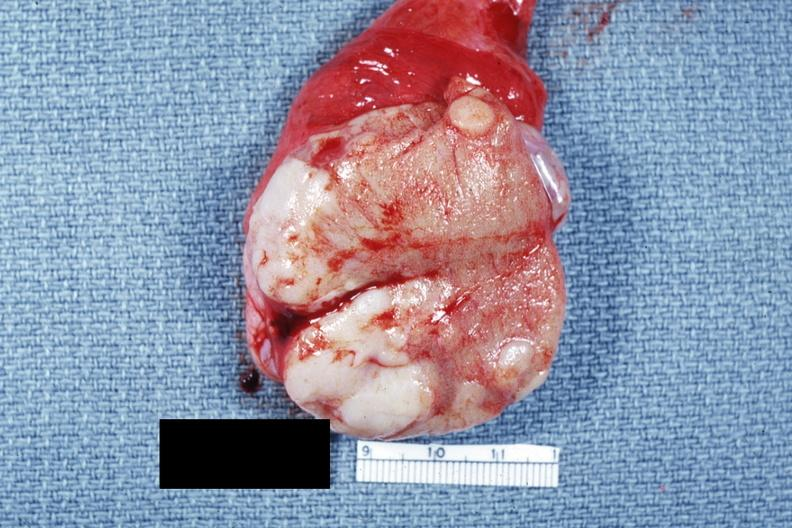how is close-up tumor well shown primary not stated said to be?
Answer the question using a single word or phrase. Adenocarcinoma 